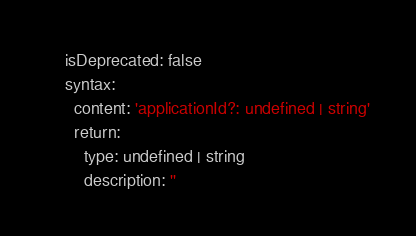Convert code to text. <code><loc_0><loc_0><loc_500><loc_500><_YAML_>    isDeprecated: false
    syntax:
      content: 'applicationId?: undefined | string'
      return:
        type: undefined | string
        description: ''
</code> 